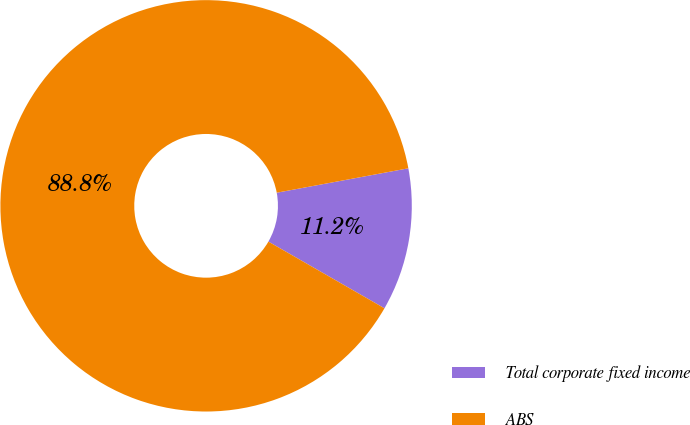Convert chart. <chart><loc_0><loc_0><loc_500><loc_500><pie_chart><fcel>Total corporate fixed income<fcel>ABS<nl><fcel>11.22%<fcel>88.78%<nl></chart> 